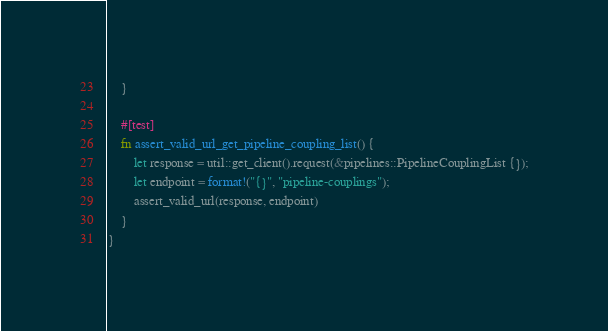Convert code to text. <code><loc_0><loc_0><loc_500><loc_500><_Rust_>    }

    #[test]
    fn assert_valid_url_get_pipeline_coupling_list() {
        let response = util::get_client().request(&pipelines::PipelineCouplingList {});
        let endpoint = format!("{}", "pipeline-couplings");
        assert_valid_url(response, endpoint)
    }
}
</code> 